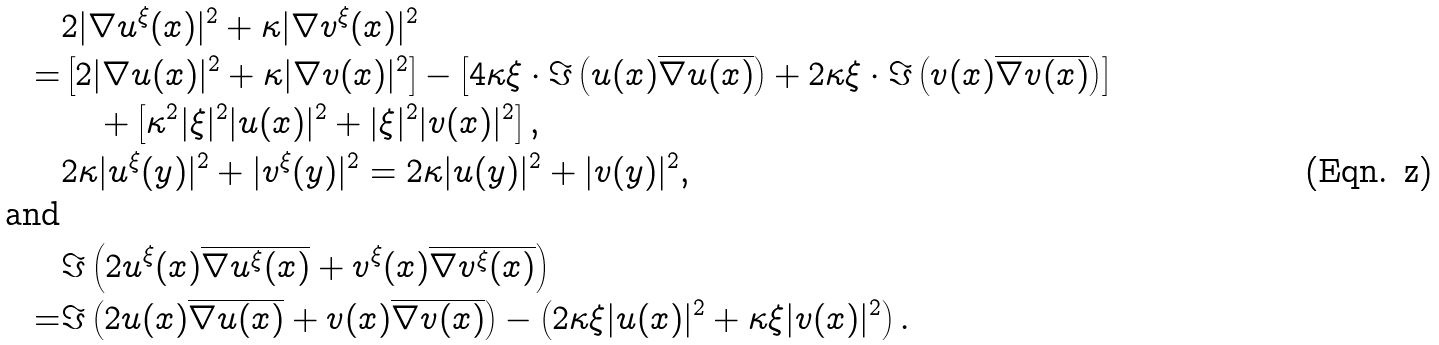<formula> <loc_0><loc_0><loc_500><loc_500>& 2 | \nabla u ^ { \xi } ( x ) | ^ { 2 } + \kappa | \nabla v ^ { \xi } ( x ) | ^ { 2 } \\ = & \left [ 2 | \nabla u ( x ) | ^ { 2 } + \kappa | \nabla v ( x ) | ^ { 2 } \right ] - \left [ 4 \kappa \xi \cdot \Im \left ( u ( x ) \overline { \nabla u ( x ) } \right ) + 2 \kappa \xi \cdot \Im \left ( v ( x ) \overline { \nabla v ( x ) } \right ) \right ] \\ & \quad + \left [ \kappa ^ { 2 } | \xi | ^ { 2 } | u ( x ) | ^ { 2 } + | \xi | ^ { 2 } | v ( x ) | ^ { 2 } \right ] , \\ & 2 \kappa | u ^ { \xi } ( y ) | ^ { 2 } + | v ^ { \xi } ( y ) | ^ { 2 } = 2 \kappa | u ( y ) | ^ { 2 } + | v ( y ) | ^ { 2 } , \\ \text {and} & \\ & \Im \left ( 2 u ^ { \xi } ( x ) \overline { \nabla u ^ { \xi } ( x ) } + v ^ { \xi } ( x ) \overline { \nabla v ^ { \xi } ( x ) } \right ) \\ = & \Im \left ( 2 u ( x ) \overline { \nabla u ( x ) } + v ( x ) \overline { \nabla v ( x ) } \right ) - \left ( 2 \kappa \xi | u ( x ) | ^ { 2 } + \kappa \xi | v ( x ) | ^ { 2 } \right ) .</formula> 